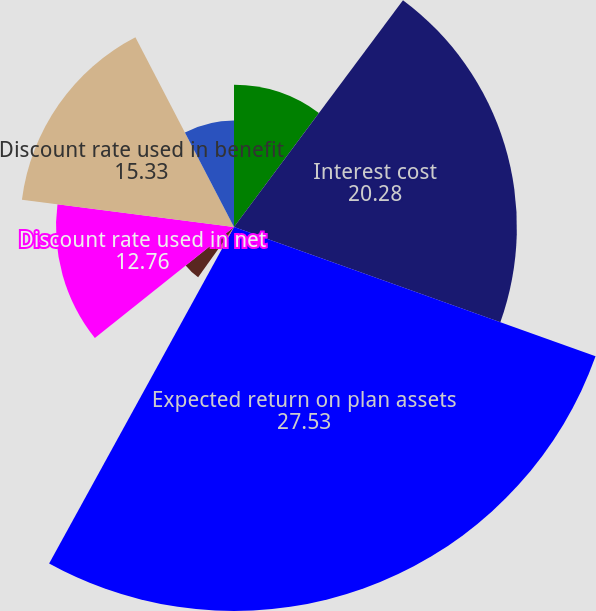<chart> <loc_0><loc_0><loc_500><loc_500><pie_chart><fcel>Service cost<fcel>Interest cost<fcel>Expected return on plan assets<fcel>Recognized net actuarial loss<fcel>Net pension expense<fcel>Discount rate used in net<fcel>Discount rate used in benefit<fcel>Rate of compensation increase<nl><fcel>10.19%<fcel>20.28%<fcel>27.53%<fcel>1.86%<fcel>4.43%<fcel>12.76%<fcel>15.33%<fcel>7.63%<nl></chart> 